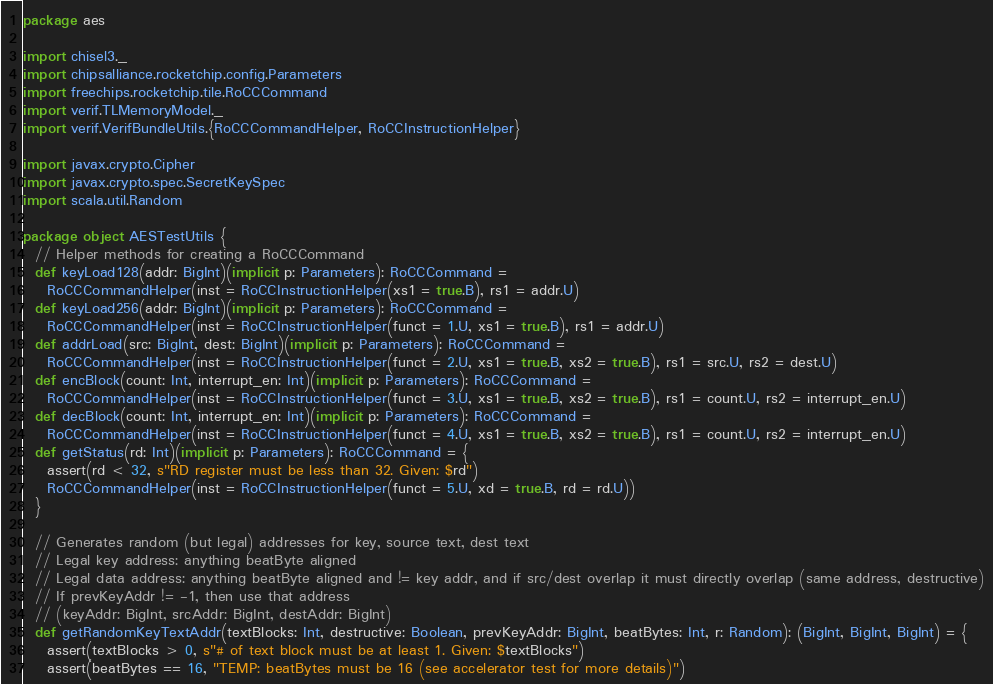<code> <loc_0><loc_0><loc_500><loc_500><_Scala_>package aes

import chisel3._
import chipsalliance.rocketchip.config.Parameters
import freechips.rocketchip.tile.RoCCCommand
import verif.TLMemoryModel._
import verif.VerifBundleUtils.{RoCCCommandHelper, RoCCInstructionHelper}

import javax.crypto.Cipher
import javax.crypto.spec.SecretKeySpec
import scala.util.Random

package object AESTestUtils {
  // Helper methods for creating a RoCCCommand
  def keyLoad128(addr: BigInt)(implicit p: Parameters): RoCCCommand =
    RoCCCommandHelper(inst = RoCCInstructionHelper(xs1 = true.B), rs1 = addr.U)
  def keyLoad256(addr: BigInt)(implicit p: Parameters): RoCCCommand =
    RoCCCommandHelper(inst = RoCCInstructionHelper(funct = 1.U, xs1 = true.B), rs1 = addr.U)
  def addrLoad(src: BigInt, dest: BigInt)(implicit p: Parameters): RoCCCommand =
    RoCCCommandHelper(inst = RoCCInstructionHelper(funct = 2.U, xs1 = true.B, xs2 = true.B), rs1 = src.U, rs2 = dest.U)
  def encBlock(count: Int, interrupt_en: Int)(implicit p: Parameters): RoCCCommand =
    RoCCCommandHelper(inst = RoCCInstructionHelper(funct = 3.U, xs1 = true.B, xs2 = true.B), rs1 = count.U, rs2 = interrupt_en.U)
  def decBlock(count: Int, interrupt_en: Int)(implicit p: Parameters): RoCCCommand =
    RoCCCommandHelper(inst = RoCCInstructionHelper(funct = 4.U, xs1 = true.B, xs2 = true.B), rs1 = count.U, rs2 = interrupt_en.U)
  def getStatus(rd: Int)(implicit p: Parameters): RoCCCommand = {
    assert(rd < 32, s"RD register must be less than 32. Given: $rd")
    RoCCCommandHelper(inst = RoCCInstructionHelper(funct = 5.U, xd = true.B, rd = rd.U))
  }

  // Generates random (but legal) addresses for key, source text, dest text
  // Legal key address: anything beatByte aligned
  // Legal data address: anything beatByte aligned and != key addr, and if src/dest overlap it must directly overlap (same address, destructive)
  // If prevKeyAddr != -1, then use that address
  // (keyAddr: BigInt, srcAddr: BigInt, destAddr: BigInt)
  def getRandomKeyTextAddr(textBlocks: Int, destructive: Boolean, prevKeyAddr: BigInt, beatBytes: Int, r: Random): (BigInt, BigInt, BigInt) = {
    assert(textBlocks > 0, s"# of text block must be at least 1. Given: $textBlocks")
    assert(beatBytes == 16, "TEMP: beatBytes must be 16 (see accelerator test for more details)")
</code> 